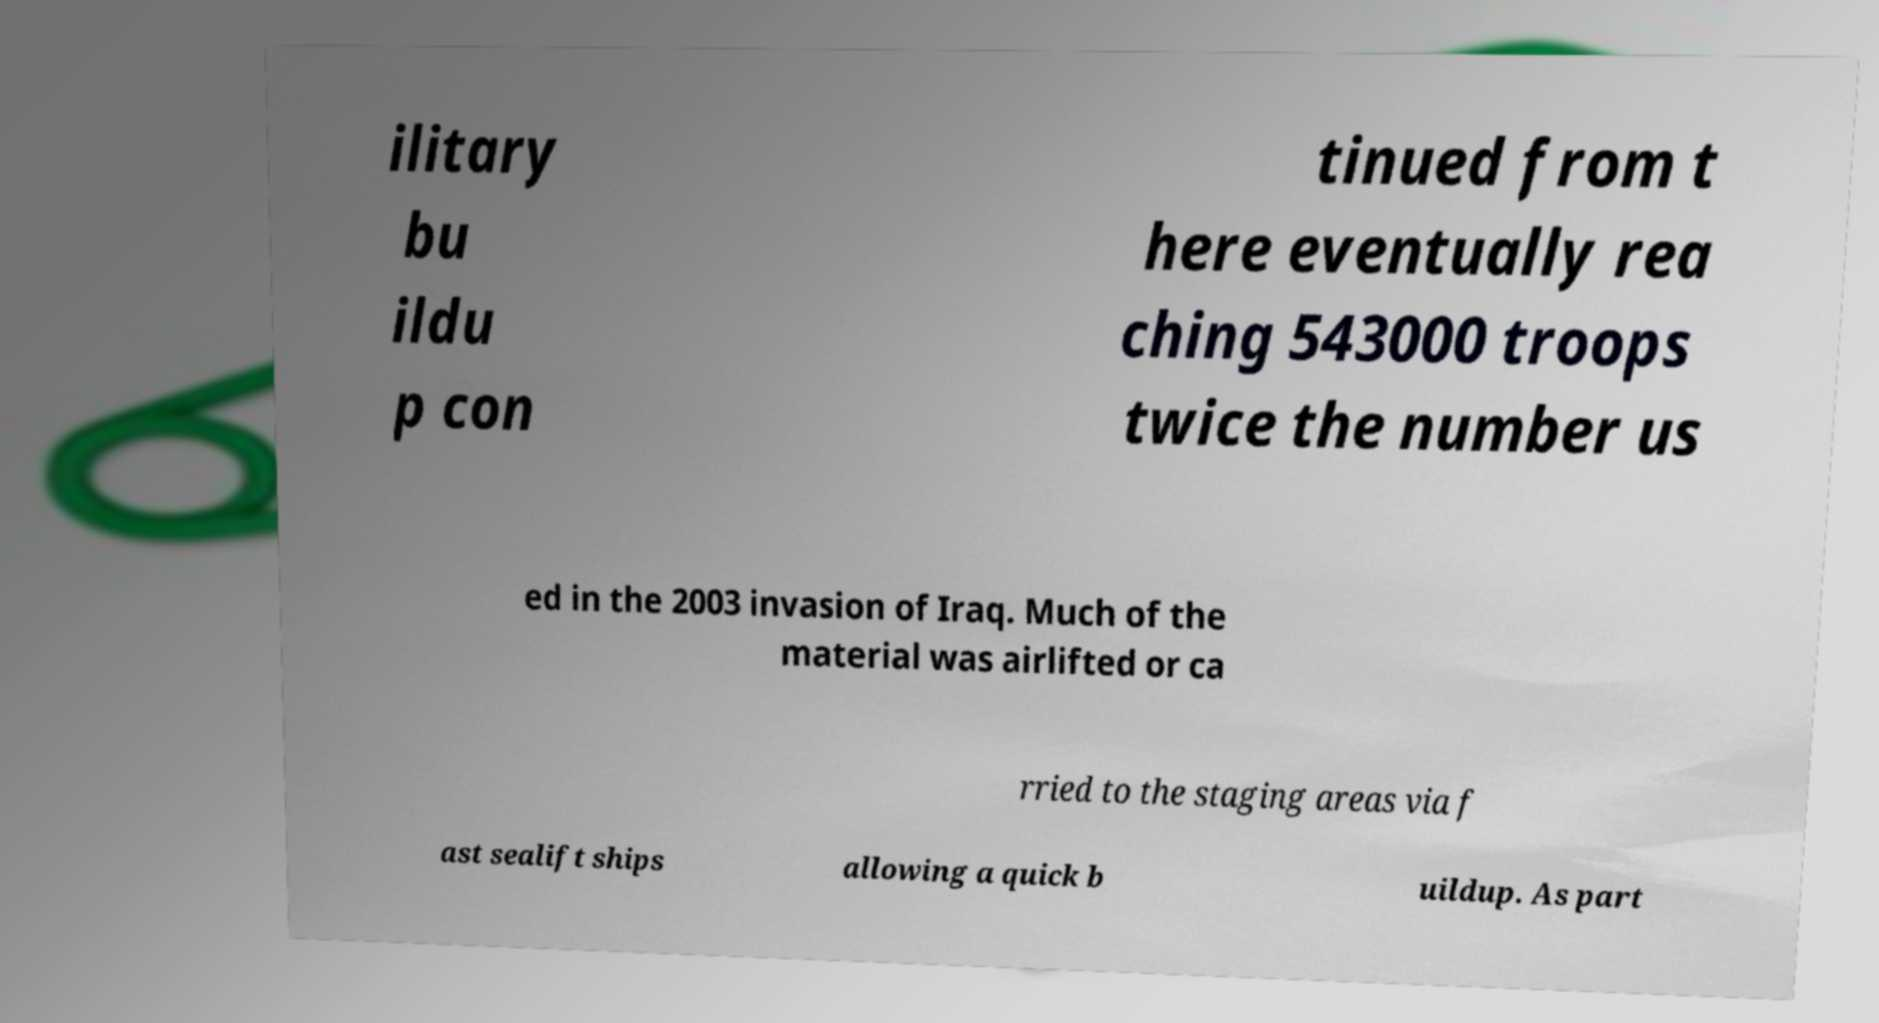What messages or text are displayed in this image? I need them in a readable, typed format. ilitary bu ildu p con tinued from t here eventually rea ching 543000 troops twice the number us ed in the 2003 invasion of Iraq. Much of the material was airlifted or ca rried to the staging areas via f ast sealift ships allowing a quick b uildup. As part 